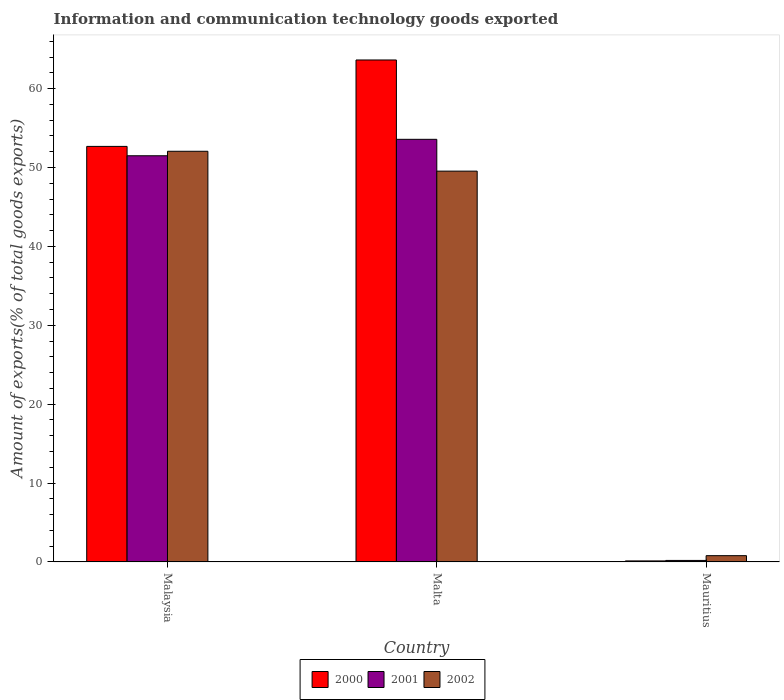How many groups of bars are there?
Ensure brevity in your answer.  3. What is the label of the 1st group of bars from the left?
Offer a terse response. Malaysia. What is the amount of goods exported in 2002 in Malta?
Provide a short and direct response. 49.54. Across all countries, what is the maximum amount of goods exported in 2001?
Provide a succinct answer. 53.58. Across all countries, what is the minimum amount of goods exported in 2001?
Provide a succinct answer. 0.19. In which country was the amount of goods exported in 2001 maximum?
Your answer should be very brief. Malta. In which country was the amount of goods exported in 2002 minimum?
Your response must be concise. Mauritius. What is the total amount of goods exported in 2002 in the graph?
Offer a very short reply. 102.4. What is the difference between the amount of goods exported in 2000 in Malaysia and that in Malta?
Make the answer very short. -10.96. What is the difference between the amount of goods exported in 2002 in Malta and the amount of goods exported in 2001 in Mauritius?
Your answer should be compact. 49.35. What is the average amount of goods exported in 2001 per country?
Provide a short and direct response. 35.09. What is the difference between the amount of goods exported of/in 2001 and amount of goods exported of/in 2002 in Mauritius?
Offer a very short reply. -0.6. In how many countries, is the amount of goods exported in 2000 greater than 54 %?
Offer a terse response. 1. What is the ratio of the amount of goods exported in 2002 in Malaysia to that in Mauritius?
Ensure brevity in your answer.  65.4. Is the difference between the amount of goods exported in 2001 in Malta and Mauritius greater than the difference between the amount of goods exported in 2002 in Malta and Mauritius?
Your answer should be very brief. Yes. What is the difference between the highest and the second highest amount of goods exported in 2001?
Your answer should be compact. -51.3. What is the difference between the highest and the lowest amount of goods exported in 2001?
Ensure brevity in your answer.  53.39. Is the sum of the amount of goods exported in 2001 in Malta and Mauritius greater than the maximum amount of goods exported in 2002 across all countries?
Ensure brevity in your answer.  Yes. What does the 2nd bar from the left in Malta represents?
Your response must be concise. 2001. What does the 1st bar from the right in Malaysia represents?
Offer a terse response. 2002. Is it the case that in every country, the sum of the amount of goods exported in 2002 and amount of goods exported in 2001 is greater than the amount of goods exported in 2000?
Provide a succinct answer. Yes. Are all the bars in the graph horizontal?
Keep it short and to the point. No. How many countries are there in the graph?
Provide a short and direct response. 3. What is the difference between two consecutive major ticks on the Y-axis?
Your answer should be very brief. 10. Are the values on the major ticks of Y-axis written in scientific E-notation?
Offer a very short reply. No. Does the graph contain any zero values?
Ensure brevity in your answer.  No. How many legend labels are there?
Offer a terse response. 3. What is the title of the graph?
Offer a terse response. Information and communication technology goods exported. What is the label or title of the Y-axis?
Keep it short and to the point. Amount of exports(% of total goods exports). What is the Amount of exports(% of total goods exports) in 2000 in Malaysia?
Make the answer very short. 52.68. What is the Amount of exports(% of total goods exports) in 2001 in Malaysia?
Give a very brief answer. 51.49. What is the Amount of exports(% of total goods exports) of 2002 in Malaysia?
Make the answer very short. 52.06. What is the Amount of exports(% of total goods exports) in 2000 in Malta?
Offer a terse response. 63.64. What is the Amount of exports(% of total goods exports) of 2001 in Malta?
Give a very brief answer. 53.58. What is the Amount of exports(% of total goods exports) in 2002 in Malta?
Provide a succinct answer. 49.54. What is the Amount of exports(% of total goods exports) of 2000 in Mauritius?
Give a very brief answer. 0.13. What is the Amount of exports(% of total goods exports) in 2001 in Mauritius?
Offer a very short reply. 0.19. What is the Amount of exports(% of total goods exports) of 2002 in Mauritius?
Offer a terse response. 0.8. Across all countries, what is the maximum Amount of exports(% of total goods exports) in 2000?
Make the answer very short. 63.64. Across all countries, what is the maximum Amount of exports(% of total goods exports) of 2001?
Give a very brief answer. 53.58. Across all countries, what is the maximum Amount of exports(% of total goods exports) of 2002?
Ensure brevity in your answer.  52.06. Across all countries, what is the minimum Amount of exports(% of total goods exports) of 2000?
Keep it short and to the point. 0.13. Across all countries, what is the minimum Amount of exports(% of total goods exports) of 2001?
Keep it short and to the point. 0.19. Across all countries, what is the minimum Amount of exports(% of total goods exports) of 2002?
Provide a short and direct response. 0.8. What is the total Amount of exports(% of total goods exports) in 2000 in the graph?
Make the answer very short. 116.45. What is the total Amount of exports(% of total goods exports) in 2001 in the graph?
Give a very brief answer. 105.26. What is the total Amount of exports(% of total goods exports) in 2002 in the graph?
Give a very brief answer. 102.4. What is the difference between the Amount of exports(% of total goods exports) of 2000 in Malaysia and that in Malta?
Your answer should be compact. -10.96. What is the difference between the Amount of exports(% of total goods exports) in 2001 in Malaysia and that in Malta?
Offer a terse response. -2.09. What is the difference between the Amount of exports(% of total goods exports) in 2002 in Malaysia and that in Malta?
Offer a very short reply. 2.52. What is the difference between the Amount of exports(% of total goods exports) in 2000 in Malaysia and that in Mauritius?
Provide a succinct answer. 52.55. What is the difference between the Amount of exports(% of total goods exports) of 2001 in Malaysia and that in Mauritius?
Your response must be concise. 51.3. What is the difference between the Amount of exports(% of total goods exports) of 2002 in Malaysia and that in Mauritius?
Make the answer very short. 51.27. What is the difference between the Amount of exports(% of total goods exports) in 2000 in Malta and that in Mauritius?
Your response must be concise. 63.51. What is the difference between the Amount of exports(% of total goods exports) in 2001 in Malta and that in Mauritius?
Offer a very short reply. 53.39. What is the difference between the Amount of exports(% of total goods exports) in 2002 in Malta and that in Mauritius?
Make the answer very short. 48.75. What is the difference between the Amount of exports(% of total goods exports) of 2000 in Malaysia and the Amount of exports(% of total goods exports) of 2001 in Malta?
Your answer should be very brief. -0.9. What is the difference between the Amount of exports(% of total goods exports) in 2000 in Malaysia and the Amount of exports(% of total goods exports) in 2002 in Malta?
Your answer should be compact. 3.14. What is the difference between the Amount of exports(% of total goods exports) of 2001 in Malaysia and the Amount of exports(% of total goods exports) of 2002 in Malta?
Offer a terse response. 1.95. What is the difference between the Amount of exports(% of total goods exports) of 2000 in Malaysia and the Amount of exports(% of total goods exports) of 2001 in Mauritius?
Offer a very short reply. 52.49. What is the difference between the Amount of exports(% of total goods exports) in 2000 in Malaysia and the Amount of exports(% of total goods exports) in 2002 in Mauritius?
Offer a very short reply. 51.88. What is the difference between the Amount of exports(% of total goods exports) of 2001 in Malaysia and the Amount of exports(% of total goods exports) of 2002 in Mauritius?
Offer a very short reply. 50.7. What is the difference between the Amount of exports(% of total goods exports) of 2000 in Malta and the Amount of exports(% of total goods exports) of 2001 in Mauritius?
Keep it short and to the point. 63.44. What is the difference between the Amount of exports(% of total goods exports) in 2000 in Malta and the Amount of exports(% of total goods exports) in 2002 in Mauritius?
Your response must be concise. 62.84. What is the difference between the Amount of exports(% of total goods exports) in 2001 in Malta and the Amount of exports(% of total goods exports) in 2002 in Mauritius?
Your answer should be very brief. 52.78. What is the average Amount of exports(% of total goods exports) in 2000 per country?
Make the answer very short. 38.82. What is the average Amount of exports(% of total goods exports) of 2001 per country?
Provide a short and direct response. 35.09. What is the average Amount of exports(% of total goods exports) of 2002 per country?
Offer a very short reply. 34.13. What is the difference between the Amount of exports(% of total goods exports) of 2000 and Amount of exports(% of total goods exports) of 2001 in Malaysia?
Your response must be concise. 1.19. What is the difference between the Amount of exports(% of total goods exports) of 2000 and Amount of exports(% of total goods exports) of 2002 in Malaysia?
Ensure brevity in your answer.  0.62. What is the difference between the Amount of exports(% of total goods exports) in 2001 and Amount of exports(% of total goods exports) in 2002 in Malaysia?
Provide a short and direct response. -0.57. What is the difference between the Amount of exports(% of total goods exports) of 2000 and Amount of exports(% of total goods exports) of 2001 in Malta?
Offer a very short reply. 10.06. What is the difference between the Amount of exports(% of total goods exports) of 2000 and Amount of exports(% of total goods exports) of 2002 in Malta?
Give a very brief answer. 14.09. What is the difference between the Amount of exports(% of total goods exports) in 2001 and Amount of exports(% of total goods exports) in 2002 in Malta?
Give a very brief answer. 4.03. What is the difference between the Amount of exports(% of total goods exports) of 2000 and Amount of exports(% of total goods exports) of 2001 in Mauritius?
Give a very brief answer. -0.06. What is the difference between the Amount of exports(% of total goods exports) in 2000 and Amount of exports(% of total goods exports) in 2002 in Mauritius?
Provide a short and direct response. -0.67. What is the difference between the Amount of exports(% of total goods exports) of 2001 and Amount of exports(% of total goods exports) of 2002 in Mauritius?
Your response must be concise. -0.6. What is the ratio of the Amount of exports(% of total goods exports) of 2000 in Malaysia to that in Malta?
Keep it short and to the point. 0.83. What is the ratio of the Amount of exports(% of total goods exports) of 2001 in Malaysia to that in Malta?
Provide a succinct answer. 0.96. What is the ratio of the Amount of exports(% of total goods exports) of 2002 in Malaysia to that in Malta?
Your answer should be compact. 1.05. What is the ratio of the Amount of exports(% of total goods exports) of 2000 in Malaysia to that in Mauritius?
Keep it short and to the point. 405.98. What is the ratio of the Amount of exports(% of total goods exports) in 2001 in Malaysia to that in Mauritius?
Your answer should be compact. 267.81. What is the ratio of the Amount of exports(% of total goods exports) of 2002 in Malaysia to that in Mauritius?
Offer a terse response. 65.4. What is the ratio of the Amount of exports(% of total goods exports) of 2000 in Malta to that in Mauritius?
Your response must be concise. 490.41. What is the ratio of the Amount of exports(% of total goods exports) in 2001 in Malta to that in Mauritius?
Your answer should be compact. 278.66. What is the ratio of the Amount of exports(% of total goods exports) in 2002 in Malta to that in Mauritius?
Give a very brief answer. 62.24. What is the difference between the highest and the second highest Amount of exports(% of total goods exports) in 2000?
Provide a succinct answer. 10.96. What is the difference between the highest and the second highest Amount of exports(% of total goods exports) of 2001?
Make the answer very short. 2.09. What is the difference between the highest and the second highest Amount of exports(% of total goods exports) of 2002?
Give a very brief answer. 2.52. What is the difference between the highest and the lowest Amount of exports(% of total goods exports) in 2000?
Your answer should be compact. 63.51. What is the difference between the highest and the lowest Amount of exports(% of total goods exports) of 2001?
Keep it short and to the point. 53.39. What is the difference between the highest and the lowest Amount of exports(% of total goods exports) in 2002?
Provide a short and direct response. 51.27. 